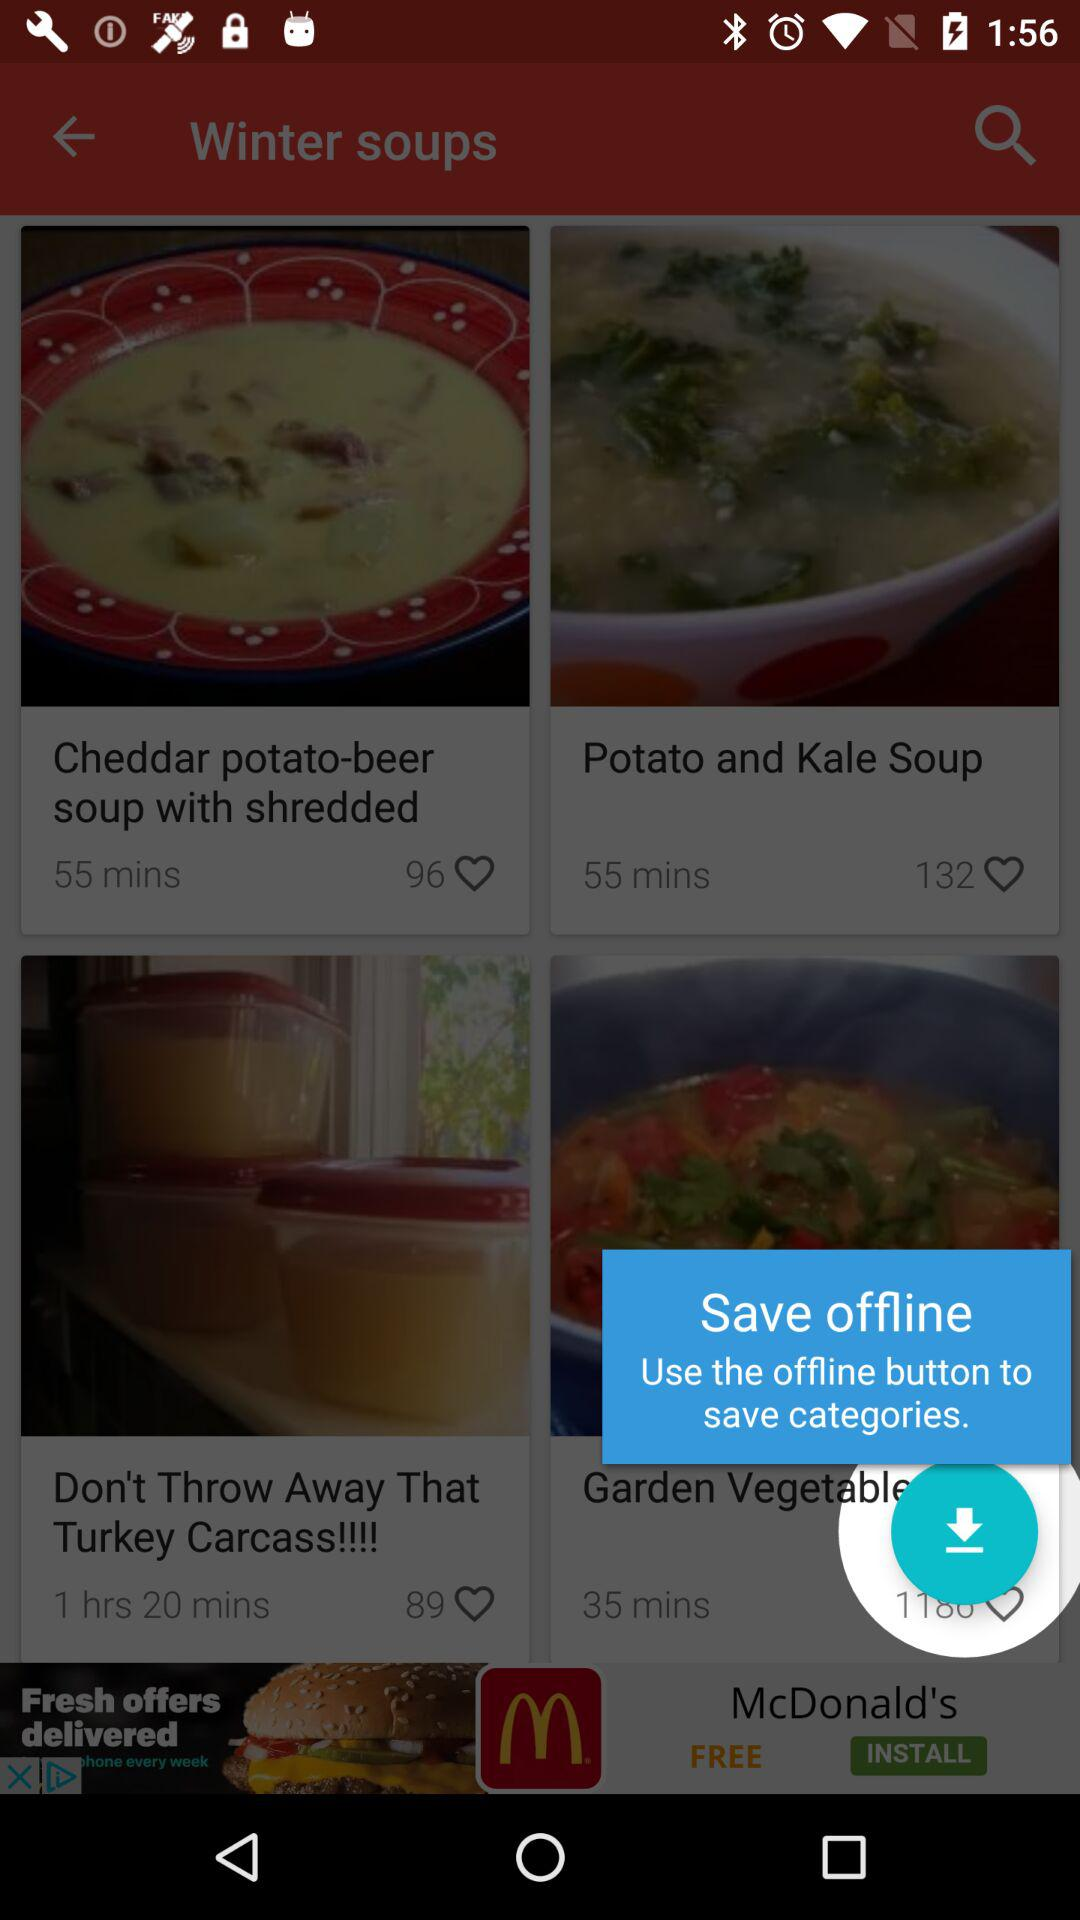Which soup has the maximum time?
When the provided information is insufficient, respond with <no answer>. <no answer> 